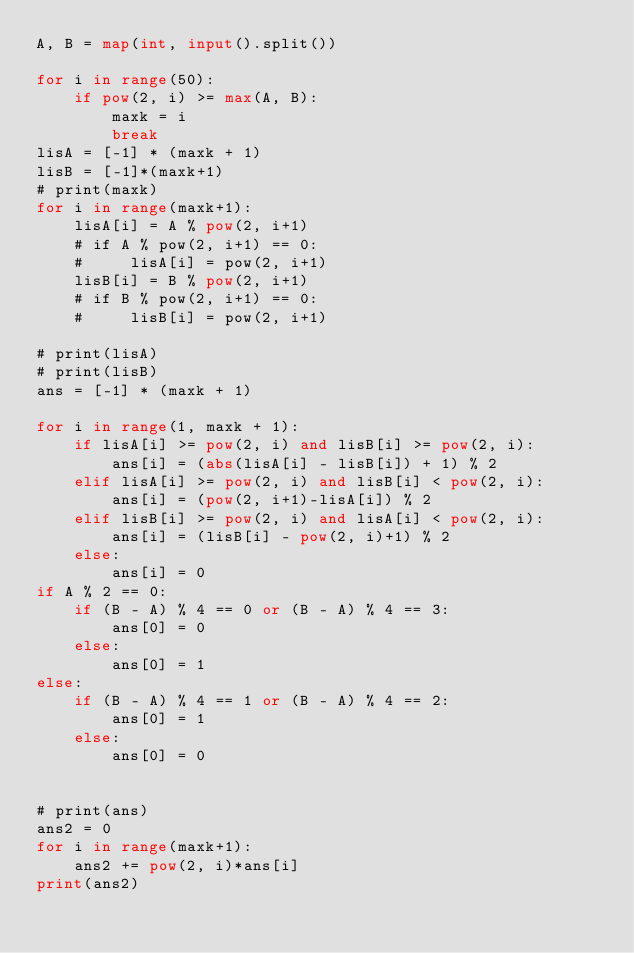<code> <loc_0><loc_0><loc_500><loc_500><_Python_>A, B = map(int, input().split())

for i in range(50):
    if pow(2, i) >= max(A, B):
        maxk = i
        break
lisA = [-1] * (maxk + 1)
lisB = [-1]*(maxk+1)
# print(maxk)
for i in range(maxk+1):
    lisA[i] = A % pow(2, i+1)
    # if A % pow(2, i+1) == 0:
    #     lisA[i] = pow(2, i+1)
    lisB[i] = B % pow(2, i+1)
    # if B % pow(2, i+1) == 0:
    #     lisB[i] = pow(2, i+1)

# print(lisA)
# print(lisB)
ans = [-1] * (maxk + 1)

for i in range(1, maxk + 1):
    if lisA[i] >= pow(2, i) and lisB[i] >= pow(2, i):
        ans[i] = (abs(lisA[i] - lisB[i]) + 1) % 2
    elif lisA[i] >= pow(2, i) and lisB[i] < pow(2, i):
        ans[i] = (pow(2, i+1)-lisA[i]) % 2
    elif lisB[i] >= pow(2, i) and lisA[i] < pow(2, i):
        ans[i] = (lisB[i] - pow(2, i)+1) % 2
    else:
        ans[i] = 0
if A % 2 == 0:
    if (B - A) % 4 == 0 or (B - A) % 4 == 3:
        ans[0] = 0
    else:
        ans[0] = 1
else:
    if (B - A) % 4 == 1 or (B - A) % 4 == 2:
        ans[0] = 1
    else:
        ans[0] = 0


# print(ans)
ans2 = 0
for i in range(maxk+1):
    ans2 += pow(2, i)*ans[i]
print(ans2)</code> 